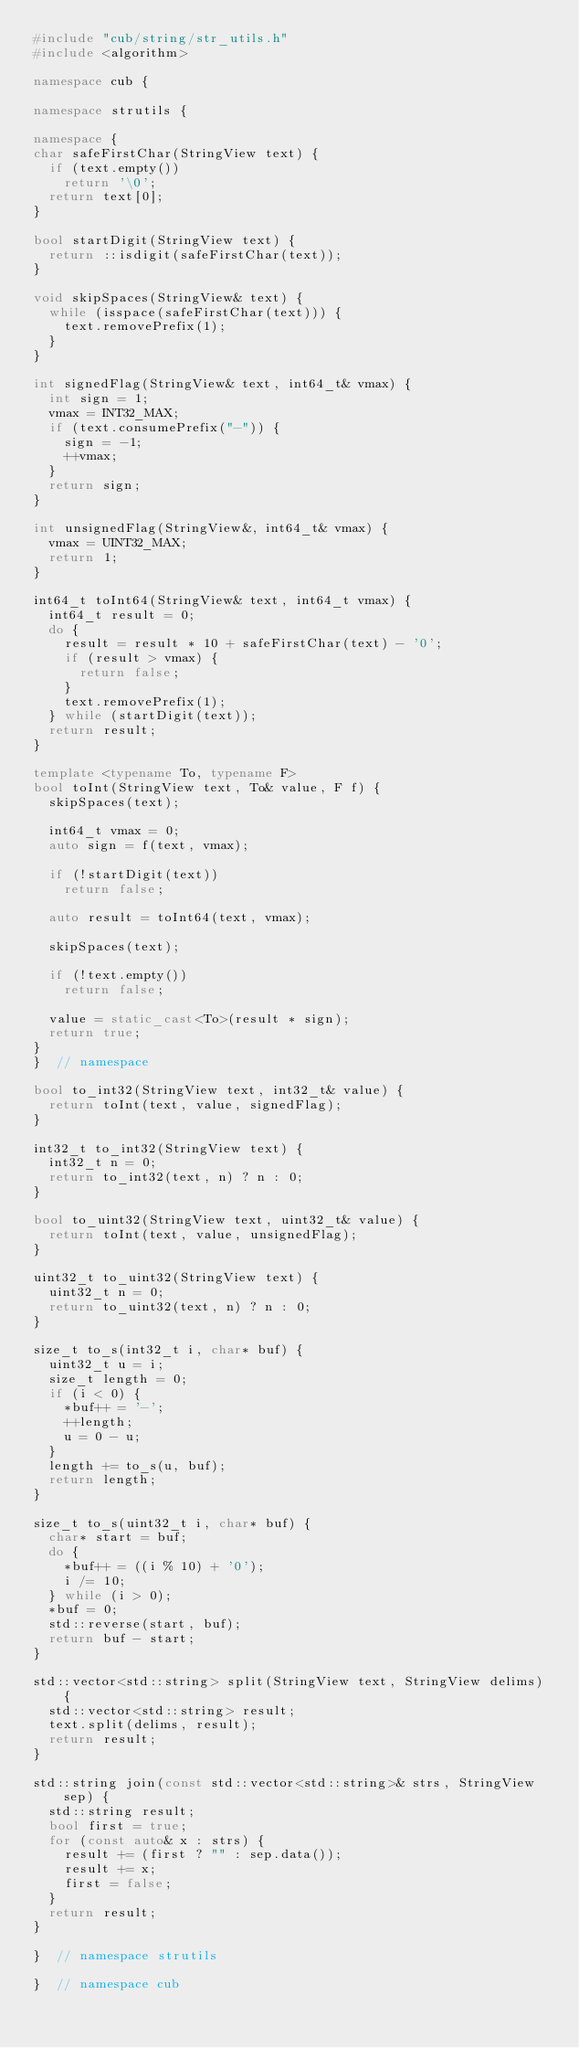Convert code to text. <code><loc_0><loc_0><loc_500><loc_500><_C++_>#include "cub/string/str_utils.h"
#include <algorithm>

namespace cub {

namespace strutils {

namespace {
char safeFirstChar(StringView text) {
  if (text.empty())
    return '\0';
  return text[0];
}

bool startDigit(StringView text) {
  return ::isdigit(safeFirstChar(text));
}

void skipSpaces(StringView& text) {
  while (isspace(safeFirstChar(text))) {
    text.removePrefix(1);
  }
}

int signedFlag(StringView& text, int64_t& vmax) {
  int sign = 1;
  vmax = INT32_MAX;
  if (text.consumePrefix("-")) {
    sign = -1;
    ++vmax;
  }
  return sign;
}

int unsignedFlag(StringView&, int64_t& vmax) {
  vmax = UINT32_MAX;
  return 1;
}

int64_t toInt64(StringView& text, int64_t vmax) {
  int64_t result = 0;
  do {
    result = result * 10 + safeFirstChar(text) - '0';
    if (result > vmax) {
      return false;
    }
    text.removePrefix(1);
  } while (startDigit(text));
  return result;
}

template <typename To, typename F>
bool toInt(StringView text, To& value, F f) {
  skipSpaces(text);

  int64_t vmax = 0;
  auto sign = f(text, vmax);

  if (!startDigit(text))
    return false;

  auto result = toInt64(text, vmax);

  skipSpaces(text);

  if (!text.empty())
    return false;

  value = static_cast<To>(result * sign);
  return true;
}
}  // namespace

bool to_int32(StringView text, int32_t& value) {
  return toInt(text, value, signedFlag);
}

int32_t to_int32(StringView text) {
  int32_t n = 0;
  return to_int32(text, n) ? n : 0;
}

bool to_uint32(StringView text, uint32_t& value) {
  return toInt(text, value, unsignedFlag);
}

uint32_t to_uint32(StringView text) {
  uint32_t n = 0;
  return to_uint32(text, n) ? n : 0;
}

size_t to_s(int32_t i, char* buf) {
  uint32_t u = i;
  size_t length = 0;
  if (i < 0) {
    *buf++ = '-';
    ++length;
    u = 0 - u;
  }
  length += to_s(u, buf);
  return length;
}

size_t to_s(uint32_t i, char* buf) {
  char* start = buf;
  do {
    *buf++ = ((i % 10) + '0');
    i /= 10;
  } while (i > 0);
  *buf = 0;
  std::reverse(start, buf);
  return buf - start;
}

std::vector<std::string> split(StringView text, StringView delims) {
  std::vector<std::string> result;
  text.split(delims, result);
  return result;
}

std::string join(const std::vector<std::string>& strs, StringView sep) {
  std::string result;
  bool first = true;
  for (const auto& x : strs) {
    result += (first ? "" : sep.data());
    result += x;
    first = false;
  }
  return result;
}

}  // namespace strutils

}  // namespace cub
</code> 